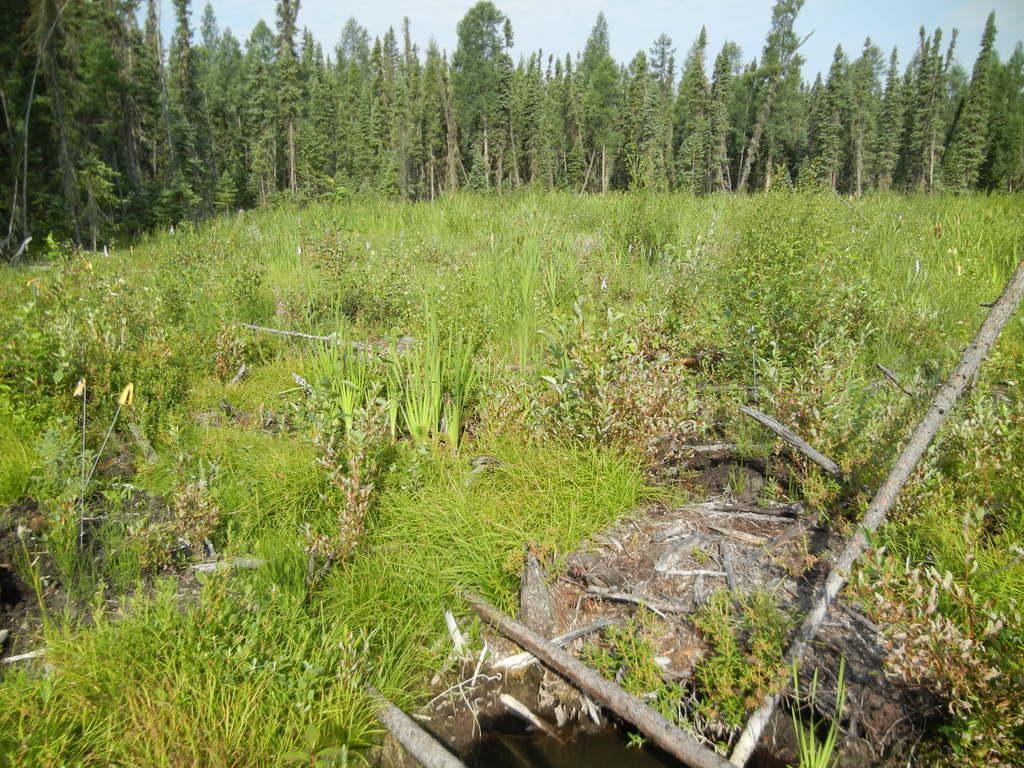Can you describe this image briefly? In this image I can see few trees, green color grass, few sticks and the sky is in blue color. 